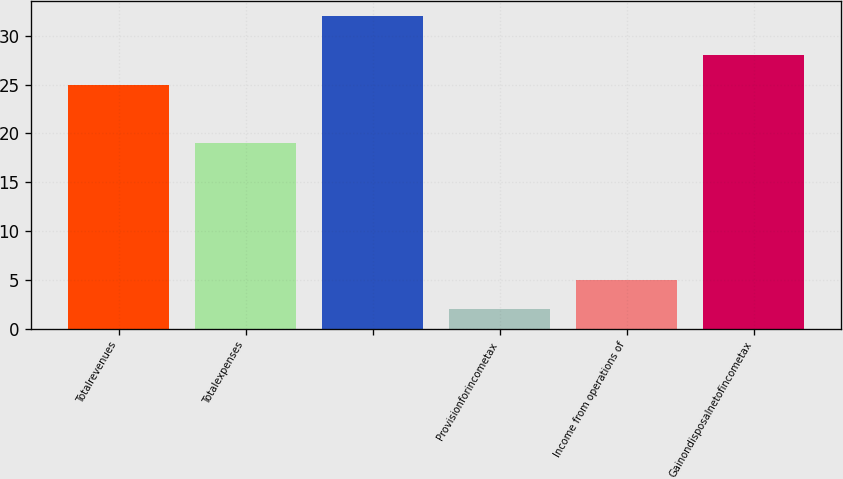Convert chart. <chart><loc_0><loc_0><loc_500><loc_500><bar_chart><fcel>Totalrevenues<fcel>Totalexpenses<fcel>Unnamed: 2<fcel>Provisionforincometax<fcel>Income from operations of<fcel>Gainondisposalnetofincometax<nl><fcel>25<fcel>19<fcel>32<fcel>2<fcel>5<fcel>28<nl></chart> 